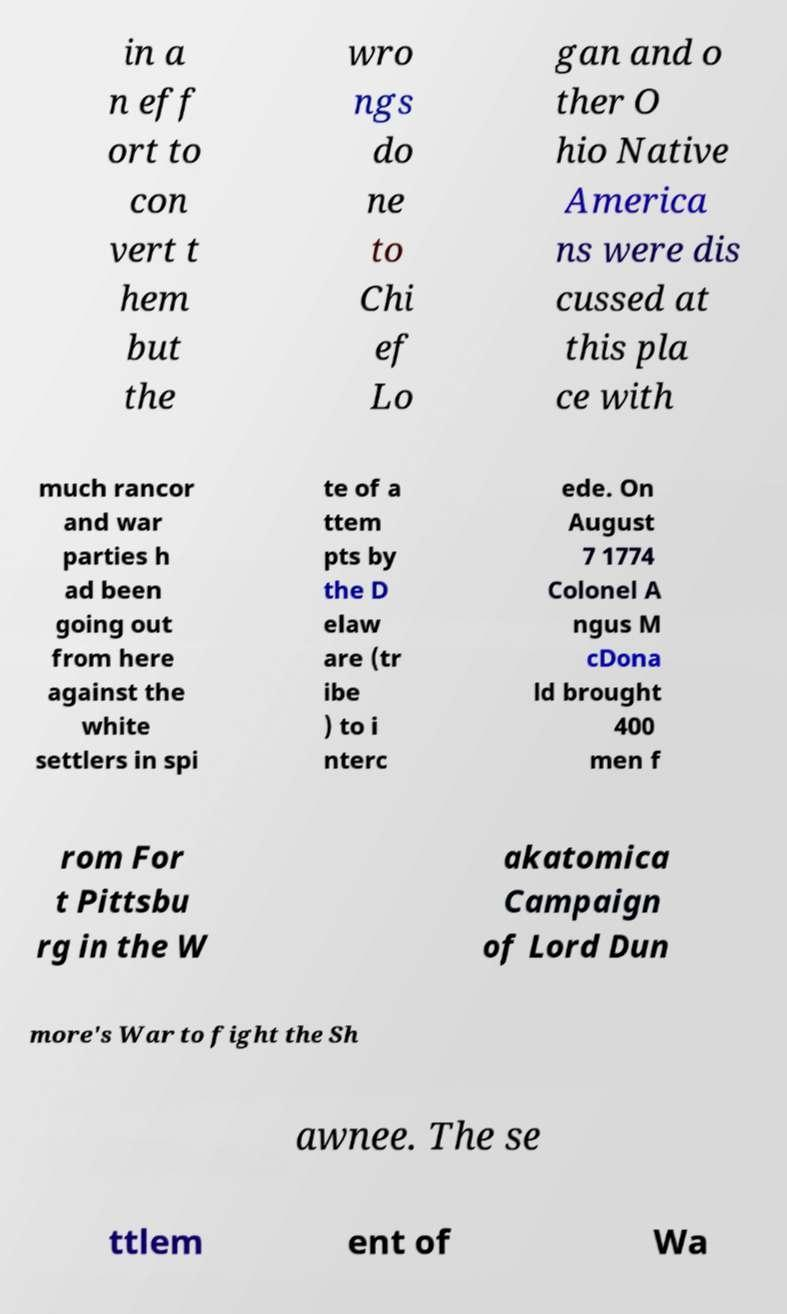Can you read and provide the text displayed in the image?This photo seems to have some interesting text. Can you extract and type it out for me? in a n eff ort to con vert t hem but the wro ngs do ne to Chi ef Lo gan and o ther O hio Native America ns were dis cussed at this pla ce with much rancor and war parties h ad been going out from here against the white settlers in spi te of a ttem pts by the D elaw are (tr ibe ) to i nterc ede. On August 7 1774 Colonel A ngus M cDona ld brought 400 men f rom For t Pittsbu rg in the W akatomica Campaign of Lord Dun more's War to fight the Sh awnee. The se ttlem ent of Wa 